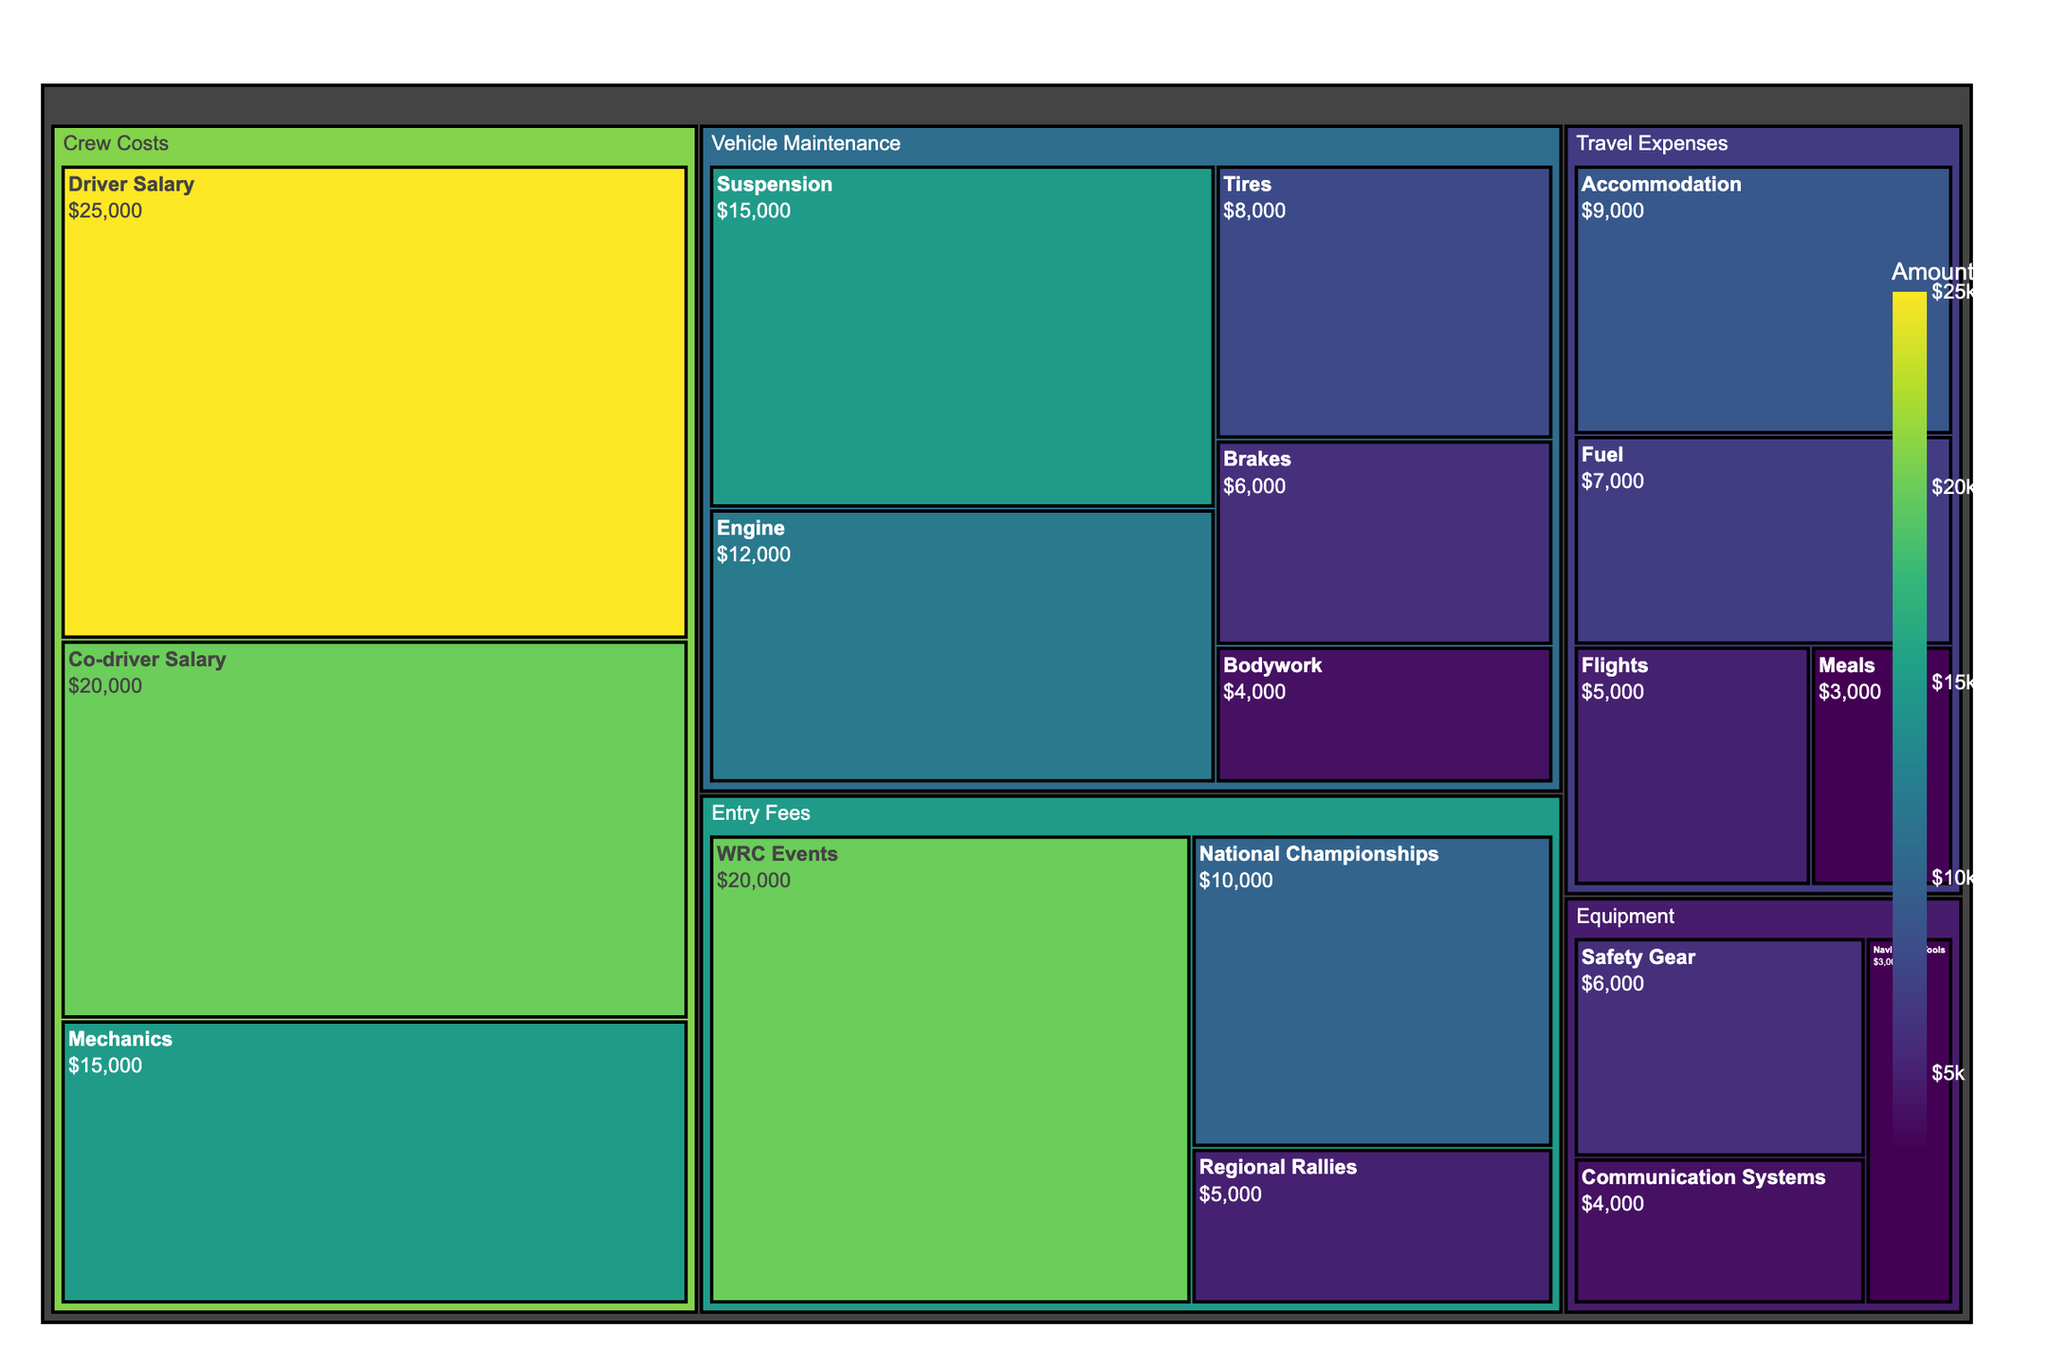What's the total budget allocated to Vehicle Maintenance? Add up all the amounts for each subcategory under Vehicle Maintenance: Suspension ($15,000) + Engine ($12,000) + Tires ($8,000) + Brakes ($6,000) + Bodywork ($4,000) = $45,000
Answer: $45,000 Which category has the highest budget allocation? Compare the total amounts for each category. Crew Costs has the largest single allocation of $25,000 for Driver Salary and $20,000 for Co-driver Salary plus $15,000 for Mechanics, amounting to $60,000, which is higher than any other categories.
Answer: Crew Costs How does the budget for Accommodation compare to the budget for Regional Rallies? Accommodation's budget is $9,000 while Regional Rallies' budget is $5,000. Accommodation is greater.
Answer: Accommodation is greater What is the combined budget for Safety Gear and Communication Systems under Equipment? Add the amounts for Safety Gear and Communication Systems: $6,000 + $4,000 = $10,000
Answer: $10,000 What's the total budget allocated to Entry Fees? Add up all the amounts for each subcategory under Entry Fees: WRC Events ($20,000) + National Championships ($10,000) + Regional Rallies ($5,000) = $35,000
Answer: $35,000 Which subcategory under Travel Expenses has the second highest budget? Travel Expenses subcategories are Accommodation ($9,000), Fuel ($7,000), Flights ($5,000), and Meals ($3,000). The second highest is Fuel.
Answer: Fuel How much more is budgeted for Driver Salary than for the Engine in Vehicle Maintenance? Subtract the amount for Engine from the amount for Driver Salary: $25,000 - $12,000 = $13,000.
Answer: $13,000 What's the largest amount allocated to an individual subcategory, and which one is it? Compare the amounts for each subcategory. The largest is Driver Salary at $25,000.
Answer: Driver Salary, $25,000 What percentage of the overall Equipment budget is allocated to Navigation Tools? First, find the total Equipment budget: Safety Gear ($6,000) + Communication Systems ($4,000) + Navigation Tools ($3,000) = $13,000. Then calculate the percentage: ($3,000 / $13,000) * 100 ≈ 23.08%.
Answer: 23.08% 